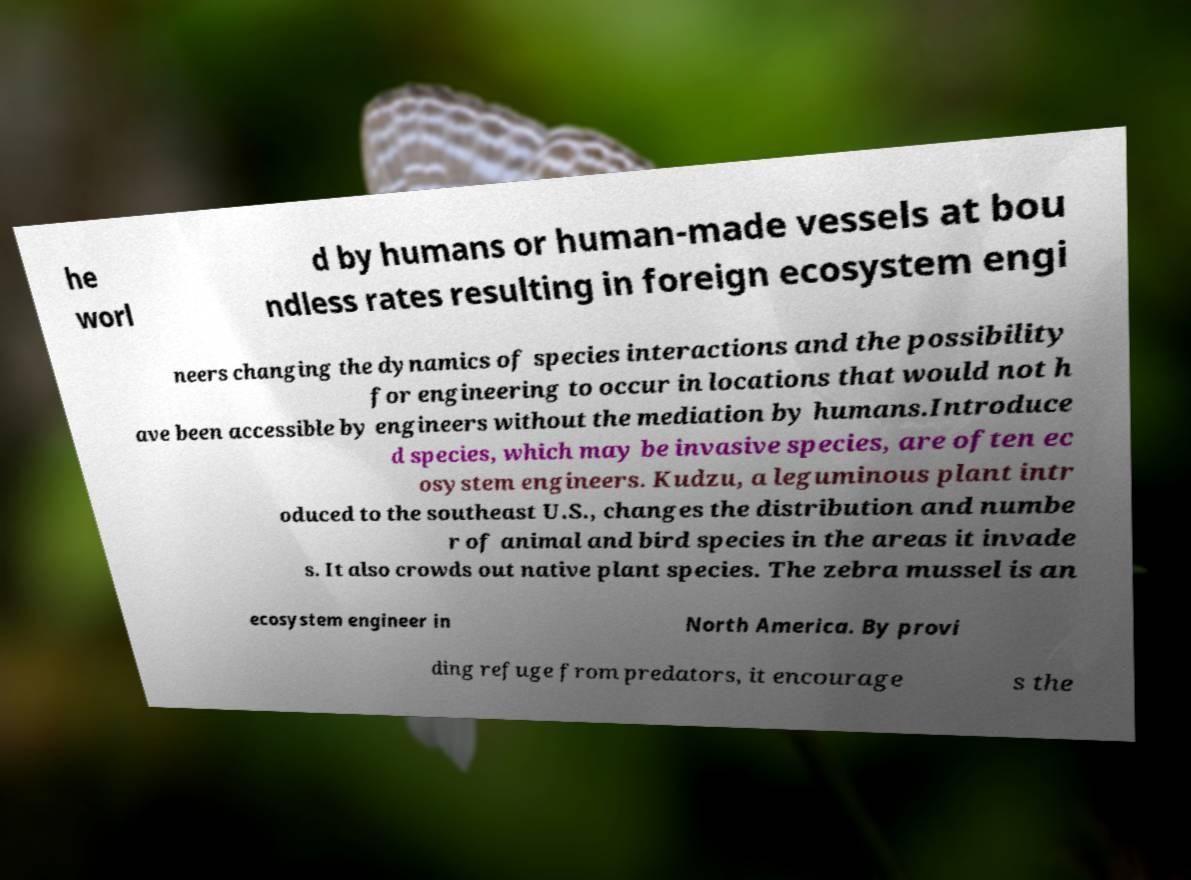There's text embedded in this image that I need extracted. Can you transcribe it verbatim? he worl d by humans or human-made vessels at bou ndless rates resulting in foreign ecosystem engi neers changing the dynamics of species interactions and the possibility for engineering to occur in locations that would not h ave been accessible by engineers without the mediation by humans.Introduce d species, which may be invasive species, are often ec osystem engineers. Kudzu, a leguminous plant intr oduced to the southeast U.S., changes the distribution and numbe r of animal and bird species in the areas it invade s. It also crowds out native plant species. The zebra mussel is an ecosystem engineer in North America. By provi ding refuge from predators, it encourage s the 